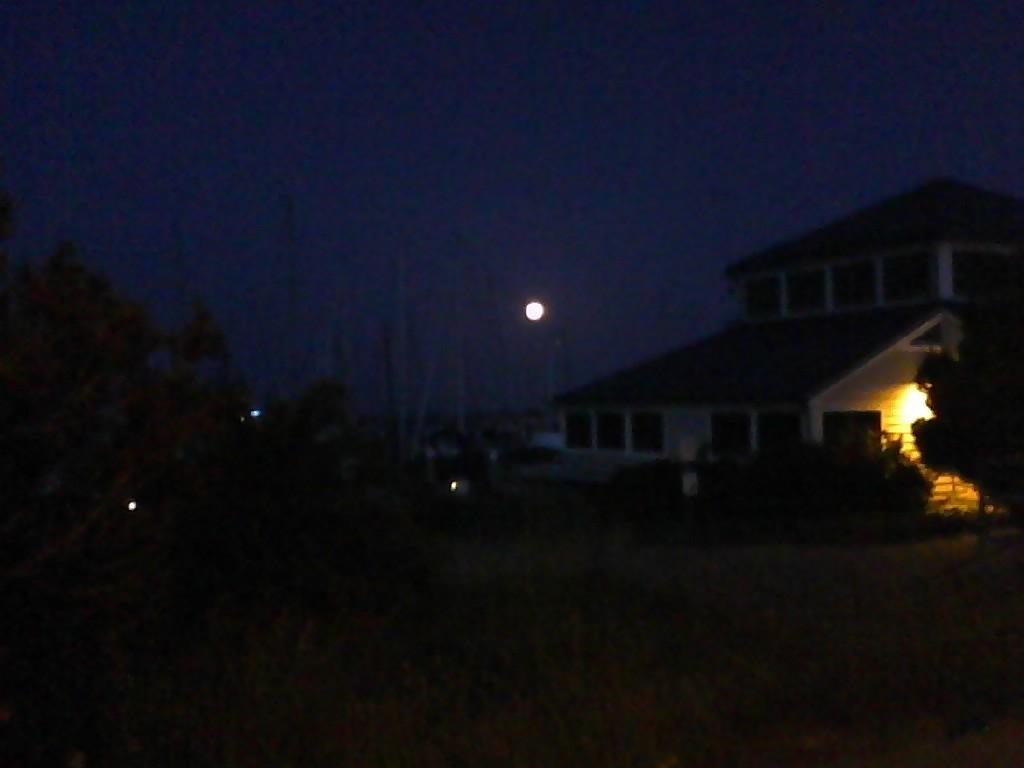What type of natural elements can be seen in the image? There are trees in the image. What type of man-made structure is present in the image? There is a building in the image. What celestial body is visible in the sky? The moon is visible in the sky. What time of day is depicted in the image? The image is set during night time. Where is the tank located in the image? There is no tank present in the image. How many babies are visible in the image? There are no babies present in the image. 